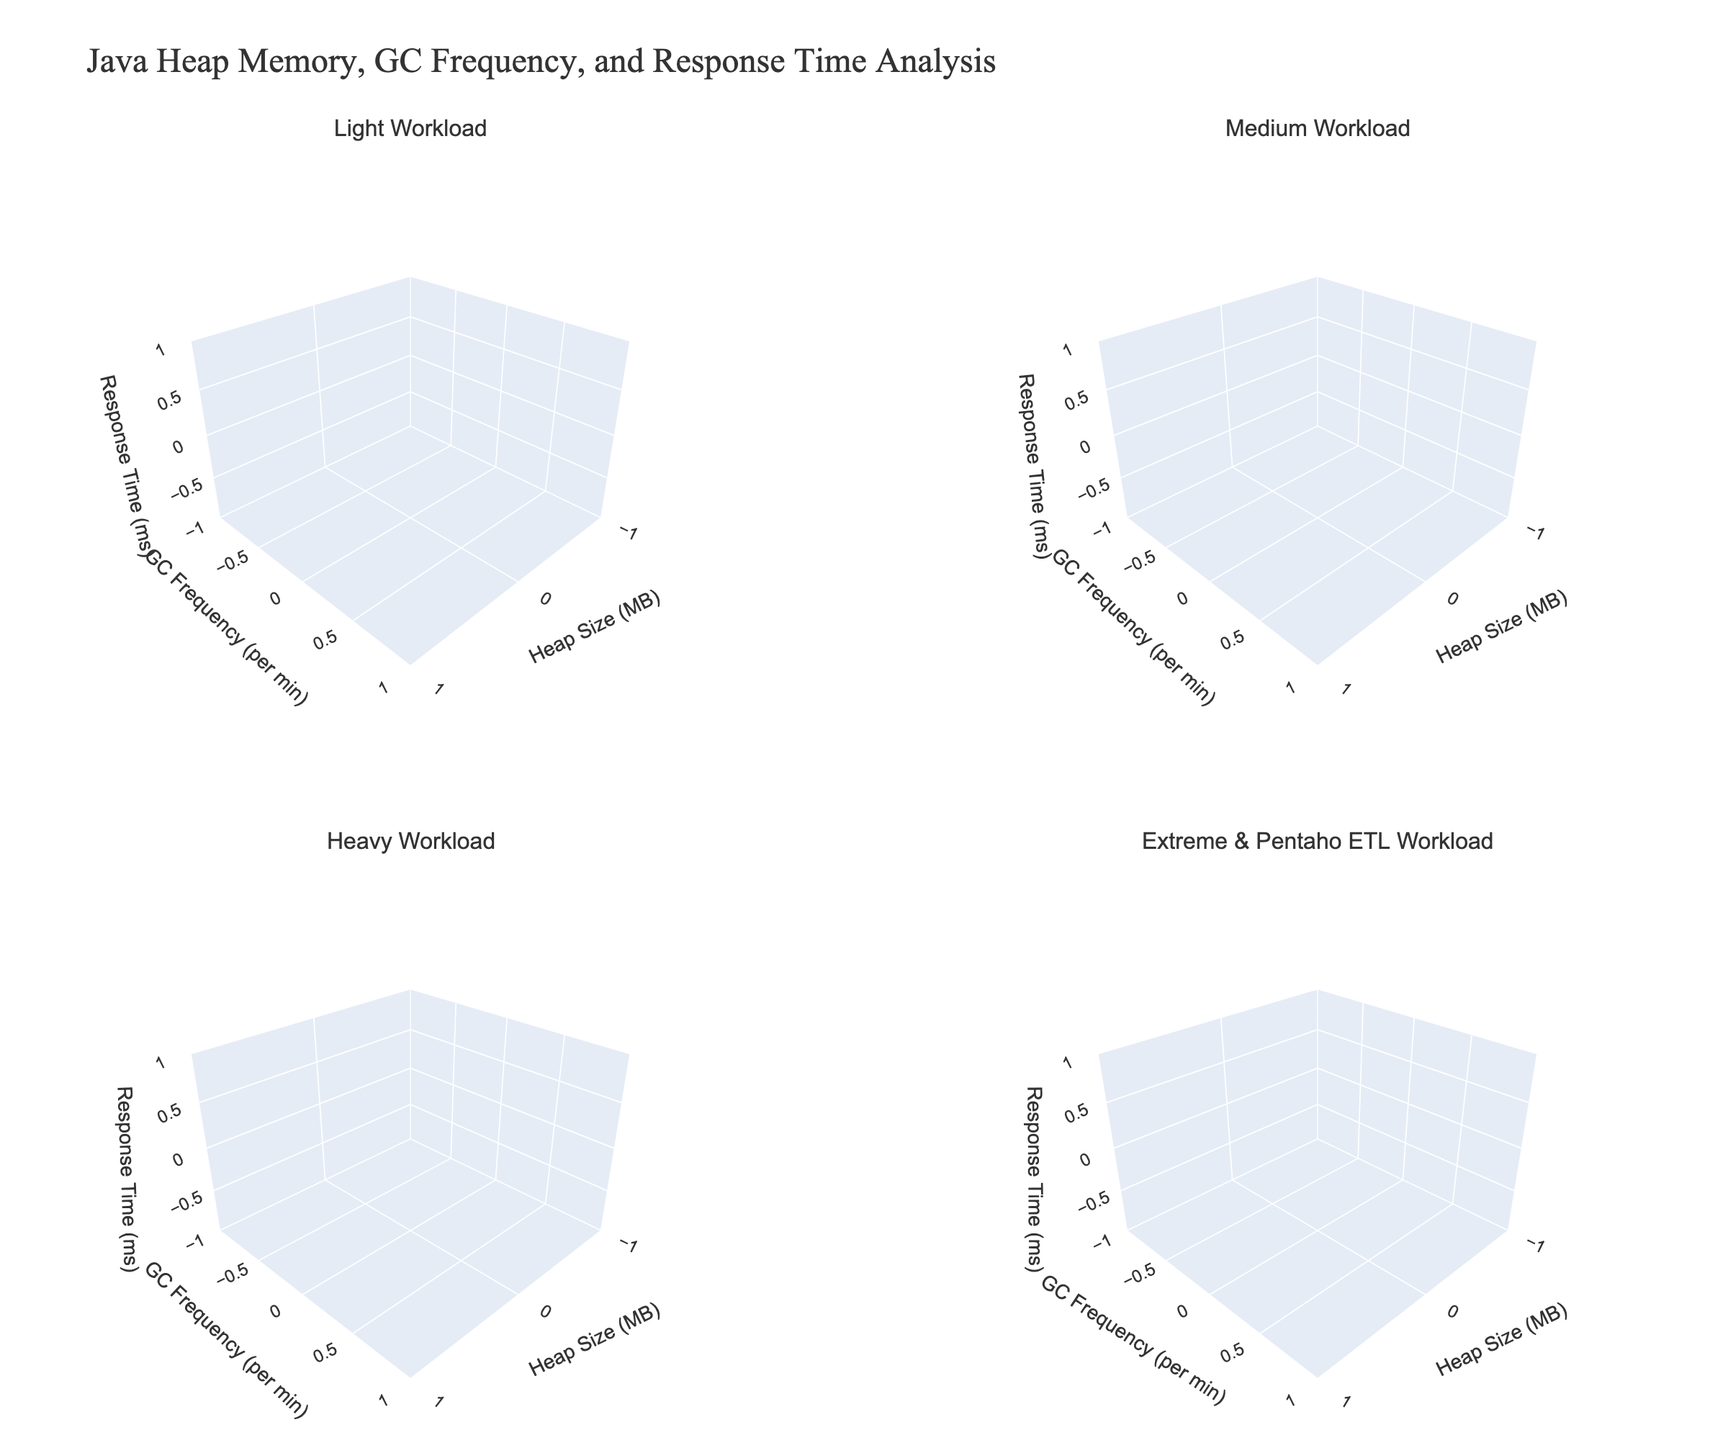What's the title of the figure? The title of the figure is prominently displayed at the top of the plot, which helps to understand the main focus of the visualization.
Answer: Java Heap Memory, GC Frequency, and Response Time Analysis What are the workloads analyzed in the subplots? The subplot titles provide direct information about the different workloads analyzed.
Answer: Light Workload, Medium Workload, Heavy Workload, Extreme & Pentaho ETL Workload In the "Light Workload" subplot, what is the range of heap size used? By looking at the x-axis in the "Light Workload" subplot, you can observe the smallest and largest heap size values.
Answer: 256 MB to 1024 MB Which workload shows the highest response time and at what heap size? The subplot titled "Extreme & Pentaho ETL Workload" contains the combined data for extreme and Pentaho ETL workloads. Visually inspecting the z-axis values and corresponding x-axis values shows the highest peak.
Answer: Extreme workload at 256 MB What happens to the garbage collection frequency as the heap size increases for the heavy workload? By tracking the y-axis values along the increasing x-axis in the "Heavy Workload" subplot, you can observe the trend.
Answer: It decreases Compare the response times for a heap size of 512 MB across all workloads. Which workload performs the best? By observing the z-axis values for x=512 MB across all subplots, the response times can be compared directly.
Answer: Light workload If the heap size is fixed at 1024 MB, which workload demonstrates the least frequent garbage collection? The "Light Workload" subplot, under x=1024 MB, shows the minimum y-axis (GC frequency) value compared to other subplots.
Answer: Light workload In the "Medium Workload" subplot, what is the response time for a heap size of 256 MB and a GC frequency of 5 per minute? Identify the specific point in the "Medium Workload" subplot that corresponds to x=256 MB and y=5 per minute and note the z-axis value.
Answer: 100 ms Find the workload with the most significant variability in response times. Comparing the z-axis ranges across subplots, the variability can be assessed by observing the difference between the highest and lowest points in each subplot.
Answer: Extreme & Pentaho ETL Workload Which workload subplot indicates the highest garbage collection frequency and what is the corresponding heap size for that value? By inspecting the peaks on the y-axis in each subplot and noting corresponding x-axis values, the highest point can be identified.
Answer: Extreme workload at 256 MB 